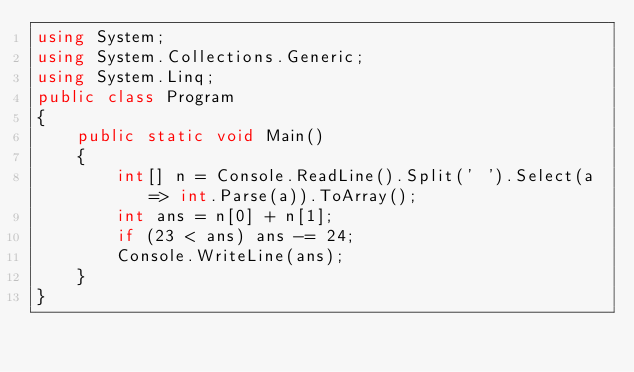<code> <loc_0><loc_0><loc_500><loc_500><_C#_>using System;
using System.Collections.Generic;
using System.Linq;
public class Program
{
    public static void Main()
    {
        int[] n = Console.ReadLine().Split(' ').Select(a => int.Parse(a)).ToArray();
        int ans = n[0] + n[1];
        if (23 < ans) ans -= 24;
        Console.WriteLine(ans);
    }
}</code> 